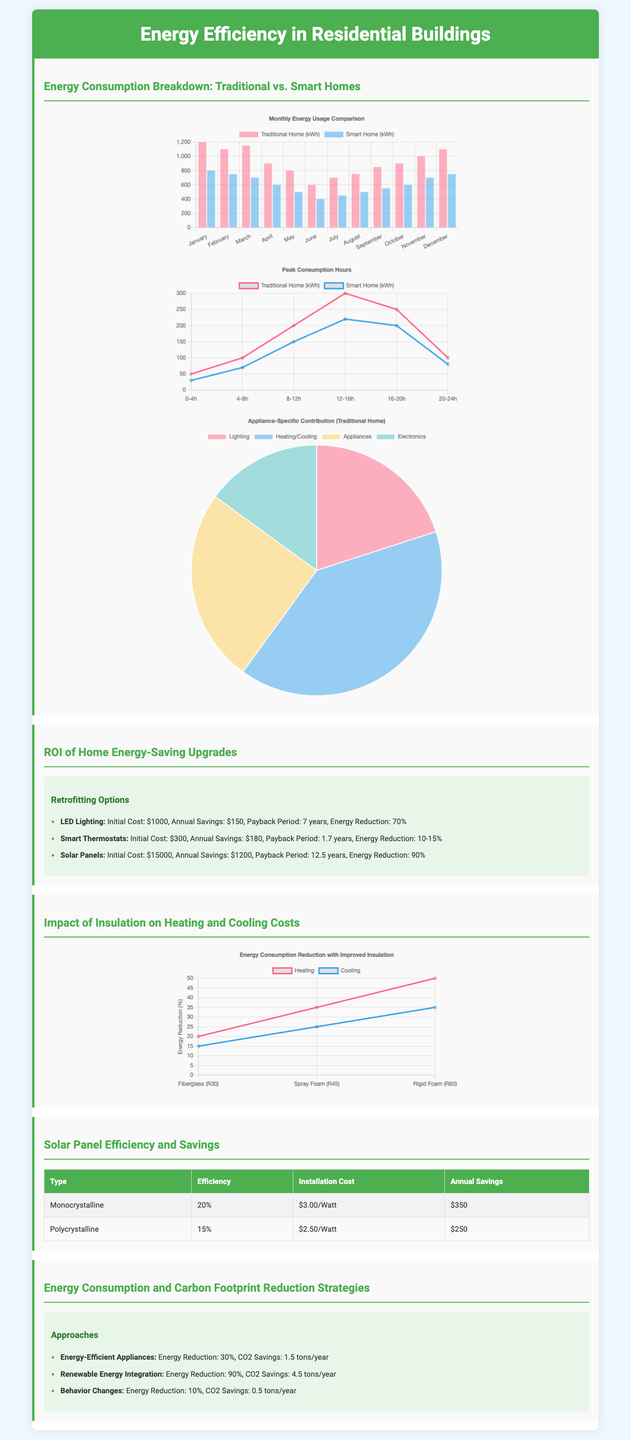What is the annual savings for smart thermostats? The annual savings is listed in the bullet points under the 'ROI of Home Energy-Saving Upgrades' section.
Answer: $180 What is the payback period for LED lighting? The payback period is noted in the same section as the initial costs and savings for each retrofitting option.
Answer: 7 years What is the efficiency of monocrystalline solar panels? The efficiency percentage is provided in the comparison table under the 'Solar Panel Efficiency and Savings' section.
Answer: 20% Which insulation material has the highest R-value? The R-values are referenced in the 'Impact of Insulation on Heating and Cooling Costs' section, comparing different insulation materials.
Answer: R60 What is the energy reduction percentage for renewable energy integration? This percentage is found in the bullet points about energy consumption and carbon footprint reduction strategies.
Answer: 90% What is the peak consumption for traditional homes during the 12-16 hour period? This information is depicted in the peak consumption hours chart.
Answer: 300 What type of chart shows appliance-specific contribution in traditional homes? The specific type is mentioned in the section that describes the appliance contribution chart.
Answer: Pie How much CO2 savings is expected from energy-efficient appliances? The CO2 savings figure is presented along with energy reduction details in the last section.
Answer: 1.5 tons/year 